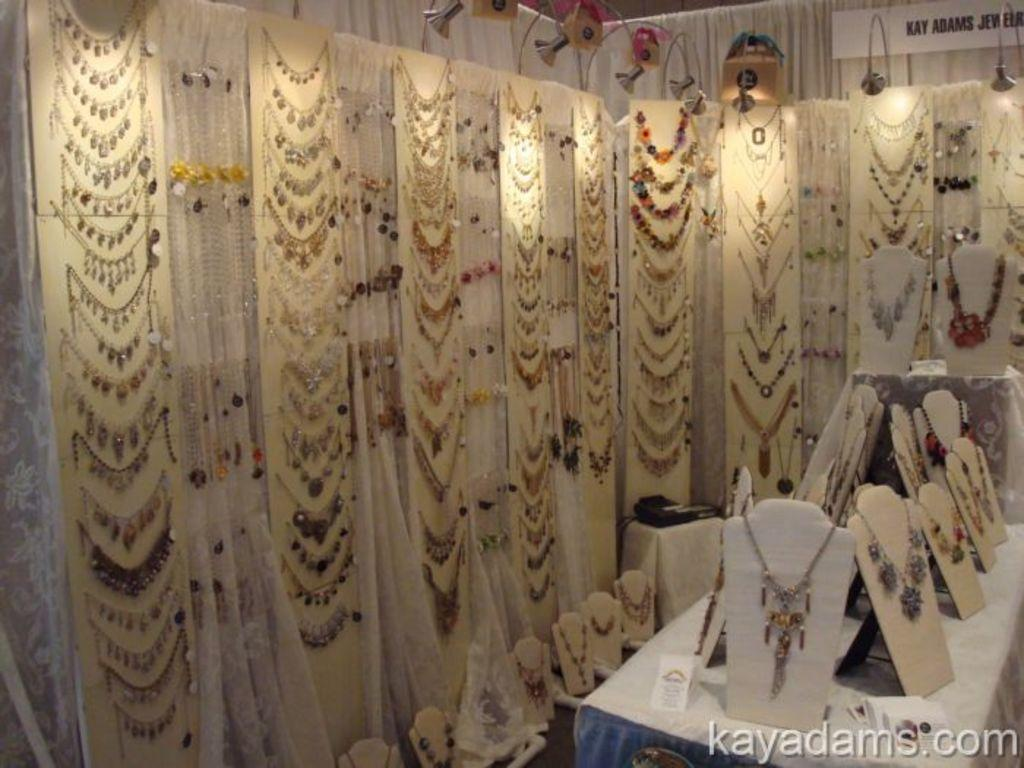What objects can be seen in the image that are decorative in nature? There are ornaments in the image. What piece of furniture is present in the image? There is a table in the image. What is written or displayed on a board in the image? There is text written on a board in the image. What type of window treatment is visible in the image? There are curtains in the image. Can you describe any additional features of the image? There is a watermark at the bottom of the image. What type of knowledge is being taught in the class depicted in the image? There is no class depicted in the image; it features ornaments, a table, text on a board, curtains, and a watermark. Can you tell me how many crackers are on the table in the image? There are no crackers present on the table in the image. 